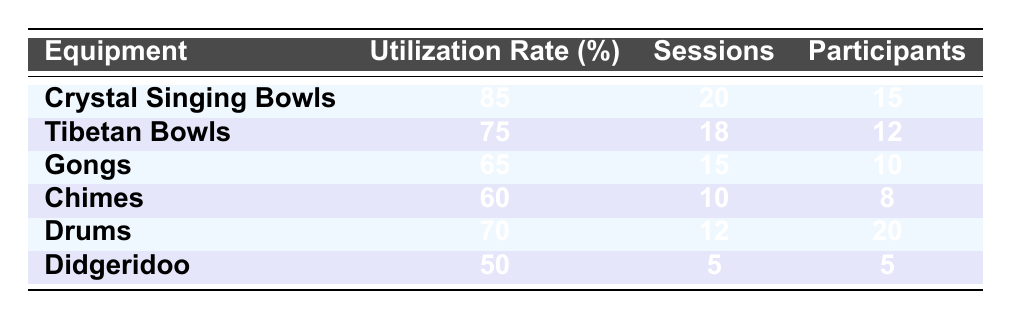What is the utilization rate of Crystal Singing Bowls? The table lists the utilization rate of each equipment. The rate for Crystal Singing Bowls is 85%.
Answer: 85% Which equipment had the highest number of sessions conducted? According to the table, the equipment with the highest sessions conducted is Crystal Singing Bowls with 20 sessions.
Answer: Crystal Singing Bowls What is the total number of participants for all equipment combined? We add the number of participants for each equipment: 15 (Crystal Singing Bowls) + 12 (Tibetan Bowls) + 10 (Gongs) + 8 (Chimes) + 20 (Drums) + 5 (Didgeridoo) = 70 participants in total.
Answer: 70 Is the utilization rate of Gongs higher than 60%? The utilization rate for Gongs is 65%, which is indeed higher than 60%. Thus, the statement is true.
Answer: Yes What is the average utilization rate of all instruments listed? We calculate the average by summing the utilization rates (85 + 75 + 65 + 60 + 70 + 50 = 405) and dividing by the number of equipment (6): 405 / 6 = 67.5%.
Answer: 67.5% Which equipment had the least number of sessions conducted? The table shows that the Didgeridoo had the least number of sessions conducted, with only 5 sessions.
Answer: Didgeridoo How many more participants were there in Drums sessions compared to Chimes sessions? The number of participants for Drums is 20 and for Chimes, it is 8. The difference is 20 - 8 = 12 more participants for Drums.
Answer: 12 Is the utilization rate of Tibetan Bowls equal to that of Drums? The utilization rate for Tibetan Bowls is 75% and for Drums it is 70%. Since these rates are not equal, the answer is false.
Answer: No What percentage of the total sessions were conducted using Gongs? First, find the total sessions: 20 + 18 + 15 + 10 + 12 + 5 = 90. Gongs had 15 sessions. Now calculate the percentage: (15 / 90) * 100 = 16.67%.
Answer: 16.67% 